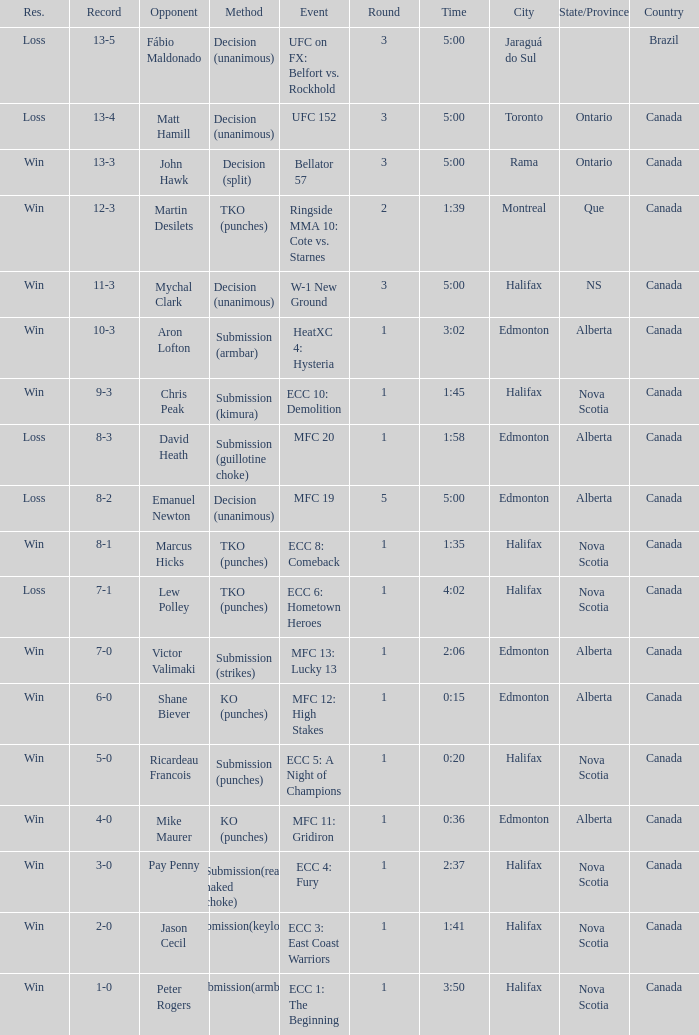What is the venue for the match against aron lofton as the opponent? Edmonton, Alberta , Canada. 